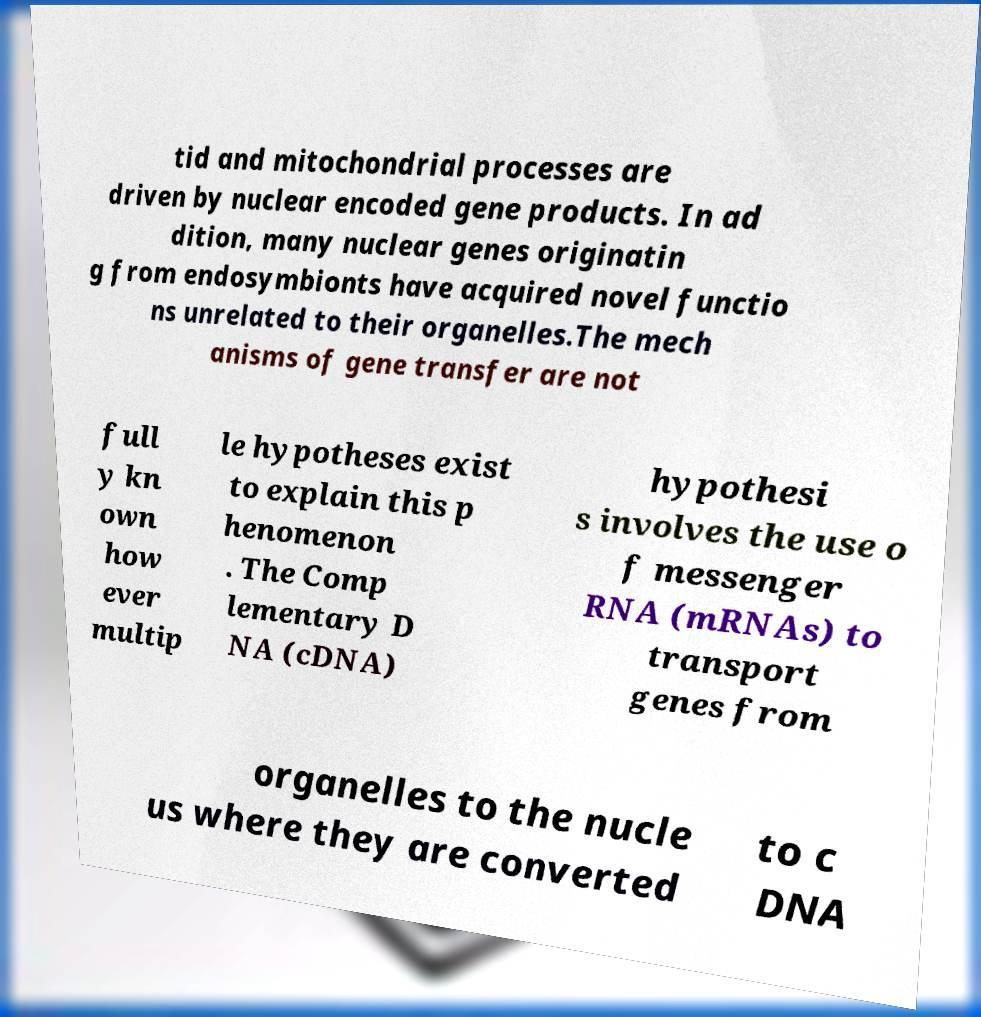What messages or text are displayed in this image? I need them in a readable, typed format. tid and mitochondrial processes are driven by nuclear encoded gene products. In ad dition, many nuclear genes originatin g from endosymbionts have acquired novel functio ns unrelated to their organelles.The mech anisms of gene transfer are not full y kn own how ever multip le hypotheses exist to explain this p henomenon . The Comp lementary D NA (cDNA) hypothesi s involves the use o f messenger RNA (mRNAs) to transport genes from organelles to the nucle us where they are converted to c DNA 